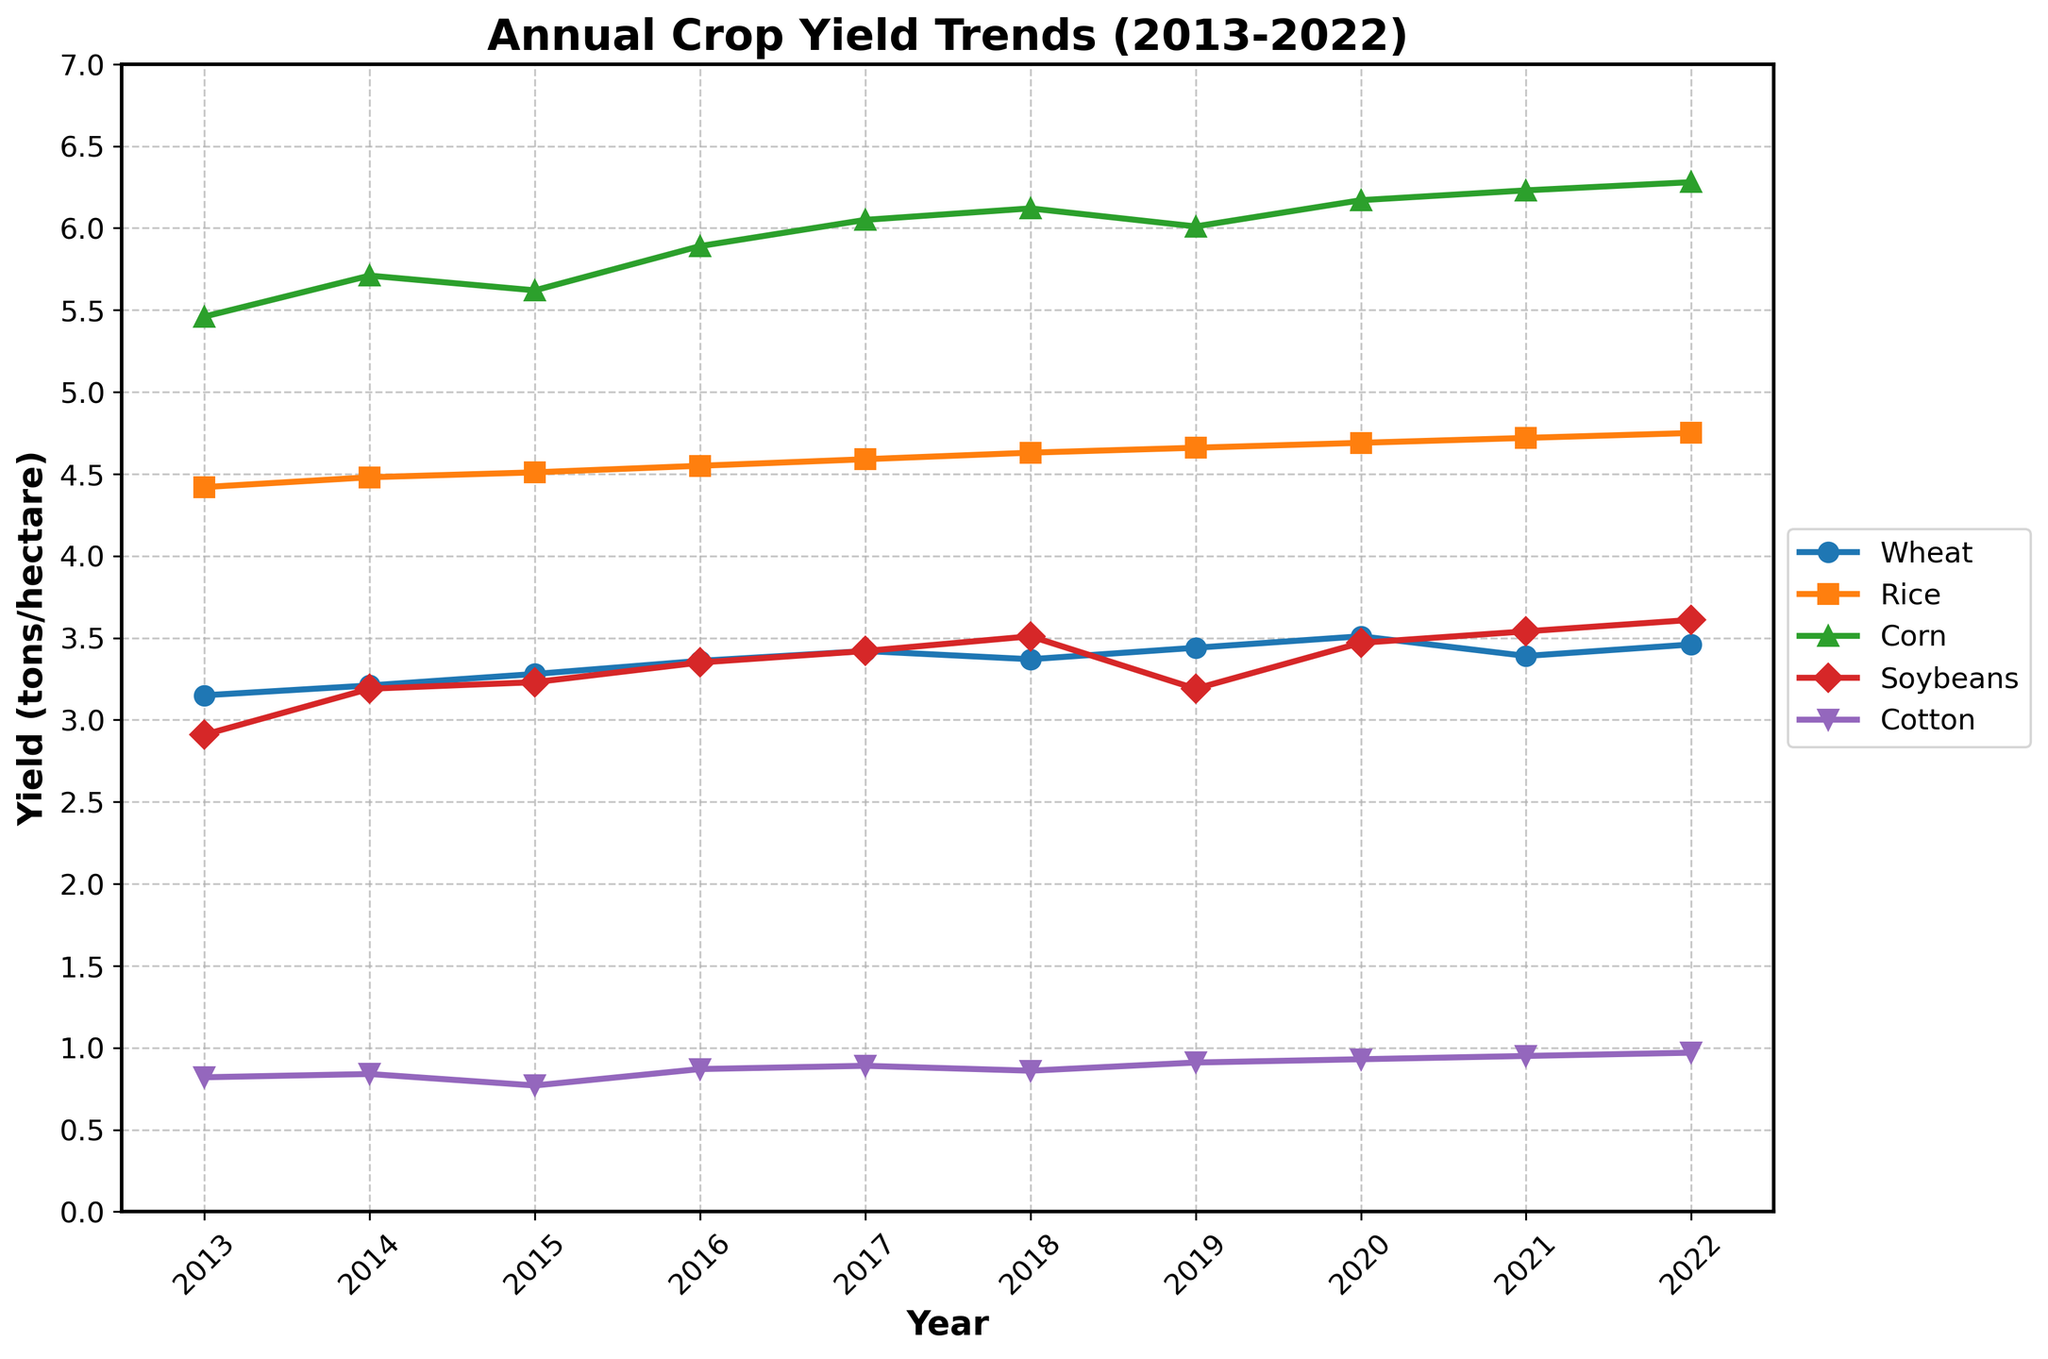Which commodity has the highest yield in 2018? To determine the highest yield in 2018, refer to the 2018 data row. Compare the values across all commodities. Corn has a yield of 6.12, which is the highest among the listed commodities for that year.
Answer: Corn How did the yield of soybeans change from 2013 to 2019? Compare the yield of soybeans in 2013 (2.91) and 2019 (3.19). Calculate the difference to understand the change: 3.19 - 2.91 = 0.28. The yield increased by 0.28 tons/hectare.
Answer: Increased by 0.28 tons/hectare Which year observed the highest yield for wheat, and what was the yield? Look through the yields of wheat across all years. The highest yield is in 2020 with a value of 3.51 tons/hectare.
Answer: 2020, 3.51 tons/hectare What is the average yield of rice from 2017 to 2022? Add the yields of rice from 2017 to 2022 and divide by the number of years. (4.59 + 4.63 + 4.66 + 4.69 + 4.72 + 4.75) / 6 = (28.04) / 6 = 4.673. The average yield is 4.673 tons/hectare.
Answer: 4.673 tons/hectare Which commodity showed the most consistent yield improvement over the decade? Assess the trends of each commodity. Improvements should be steady and consistent without major dips. Corn shows a steady increase from 5.46 in 2013 to 6.28 in 2022, indicating consistent improvement.
Answer: Corn Which commodity had the lowest yield in 2022, and what was the yield? Examine the 2022 yields for all commodities. Cotton has the lowest yield at 0.97 tons/hectare.
Answer: Cotton, 0.97 tons/hectare What is the difference in the yield of rice between the years 2013 and 2022? Compare the rice yield of 2013 (4.42) with that of 2022 (4.75), then calculate the difference: 4.75 - 4.42 = 0.33.
Answer: 0.33 tons/hectare Did the yield of cotton ever decrease compared to the previous year within the decade reported? Review the yield values of cotton for consecutive years. There is a decrease from 0.84 in 2014 to 0.77 in 2015.
Answer: Yes Can you list the years when wheat yield was above 3.40 tons/hectare? Check the data for wheat yield for each year and list the years where the value is above 3.40. The years are 2017, 2019, 2020, and 2022.
Answer: 2017, 2019, 2020, 2022 Between soybeans and rice, which one had a higher yield on average over the decade? Calculate the average yield over the decade for both soybeans and rice. Sum the annual yields and divide by 10 for each commodity. Soybeans: (2.91 + 3.19 + 3.23 + 3.35 + 3.42 + 3.51 + 3.19 + 3.47 + 3.54 + 3.61)/10 = 3.34. Rice: (4.42 + 4.48 + 4.51 + 4.55 + 4.59 + 4.63 + 4.66 + 4.69 + 4.72 + 4.75)/10 = 4.6. Rice has a higher average yield of 4.6 tons/hectare.
Answer: Rice 